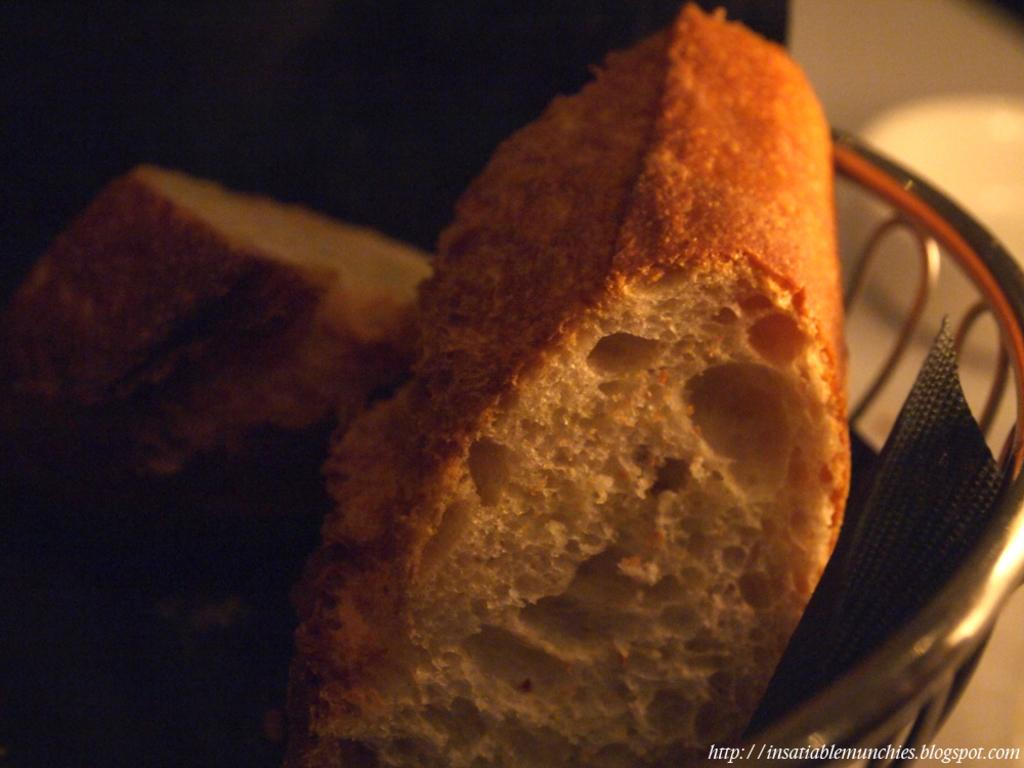What is in the bowl that is visible in the image? There is a bowl containing food items in the image. Where is the bowl located in the image? The bowl is in the center of the image. What can be found in the bottom right corner of the image? There is text in the bottom right corner of the image. Is there a stream of water flowing through the bowl in the image? No, there is no stream of water flowing through the bowl in the image. 